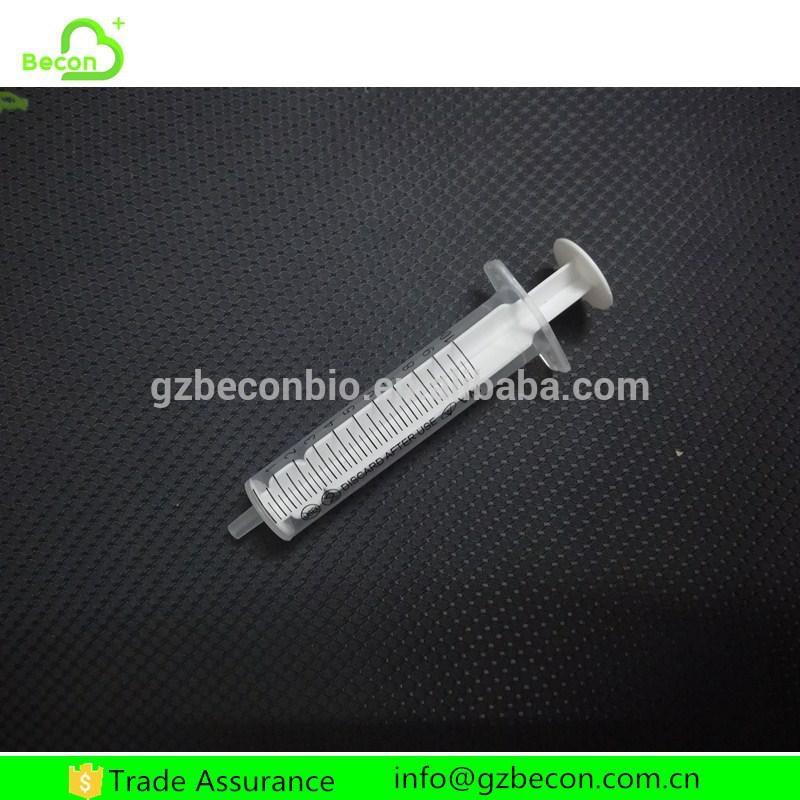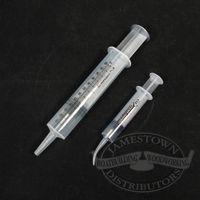The first image is the image on the left, the second image is the image on the right. Evaluate the accuracy of this statement regarding the images: "there are syringes with tubing on them". Is it true? Answer yes or no. No. The first image is the image on the left, the second image is the image on the right. Considering the images on both sides, is "There is a white wire attached to all of the syringes in one of the images, and no wires in the other image." valid? Answer yes or no. No. 